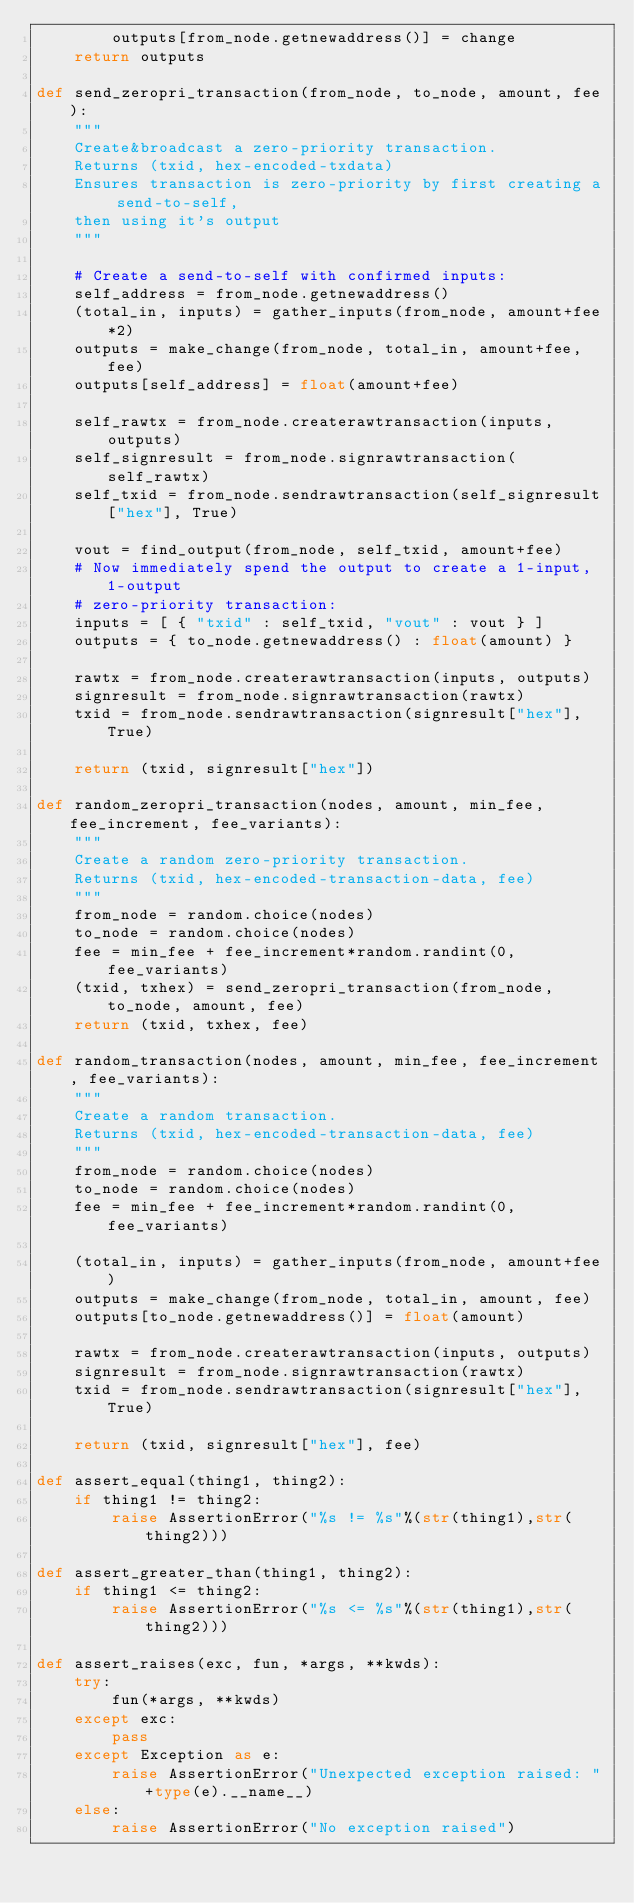Convert code to text. <code><loc_0><loc_0><loc_500><loc_500><_Python_>        outputs[from_node.getnewaddress()] = change
    return outputs

def send_zeropri_transaction(from_node, to_node, amount, fee):
    """
    Create&broadcast a zero-priority transaction.
    Returns (txid, hex-encoded-txdata)
    Ensures transaction is zero-priority by first creating a send-to-self,
    then using it's output
    """

    # Create a send-to-self with confirmed inputs:
    self_address = from_node.getnewaddress()
    (total_in, inputs) = gather_inputs(from_node, amount+fee*2)
    outputs = make_change(from_node, total_in, amount+fee, fee)
    outputs[self_address] = float(amount+fee)

    self_rawtx = from_node.createrawtransaction(inputs, outputs)
    self_signresult = from_node.signrawtransaction(self_rawtx)
    self_txid = from_node.sendrawtransaction(self_signresult["hex"], True)

    vout = find_output(from_node, self_txid, amount+fee)
    # Now immediately spend the output to create a 1-input, 1-output
    # zero-priority transaction:
    inputs = [ { "txid" : self_txid, "vout" : vout } ]
    outputs = { to_node.getnewaddress() : float(amount) }

    rawtx = from_node.createrawtransaction(inputs, outputs)
    signresult = from_node.signrawtransaction(rawtx)
    txid = from_node.sendrawtransaction(signresult["hex"], True)

    return (txid, signresult["hex"])

def random_zeropri_transaction(nodes, amount, min_fee, fee_increment, fee_variants):
    """
    Create a random zero-priority transaction.
    Returns (txid, hex-encoded-transaction-data, fee)
    """
    from_node = random.choice(nodes)
    to_node = random.choice(nodes)
    fee = min_fee + fee_increment*random.randint(0,fee_variants)
    (txid, txhex) = send_zeropri_transaction(from_node, to_node, amount, fee)
    return (txid, txhex, fee)

def random_transaction(nodes, amount, min_fee, fee_increment, fee_variants):
    """
    Create a random transaction.
    Returns (txid, hex-encoded-transaction-data, fee)
    """
    from_node = random.choice(nodes)
    to_node = random.choice(nodes)
    fee = min_fee + fee_increment*random.randint(0,fee_variants)

    (total_in, inputs) = gather_inputs(from_node, amount+fee)
    outputs = make_change(from_node, total_in, amount, fee)
    outputs[to_node.getnewaddress()] = float(amount)

    rawtx = from_node.createrawtransaction(inputs, outputs)
    signresult = from_node.signrawtransaction(rawtx)
    txid = from_node.sendrawtransaction(signresult["hex"], True)

    return (txid, signresult["hex"], fee)

def assert_equal(thing1, thing2):
    if thing1 != thing2:
        raise AssertionError("%s != %s"%(str(thing1),str(thing2)))

def assert_greater_than(thing1, thing2):
    if thing1 <= thing2:
        raise AssertionError("%s <= %s"%(str(thing1),str(thing2)))

def assert_raises(exc, fun, *args, **kwds):
    try:
        fun(*args, **kwds)
    except exc:
        pass
    except Exception as e:
        raise AssertionError("Unexpected exception raised: "+type(e).__name__)
    else:
        raise AssertionError("No exception raised")
</code> 